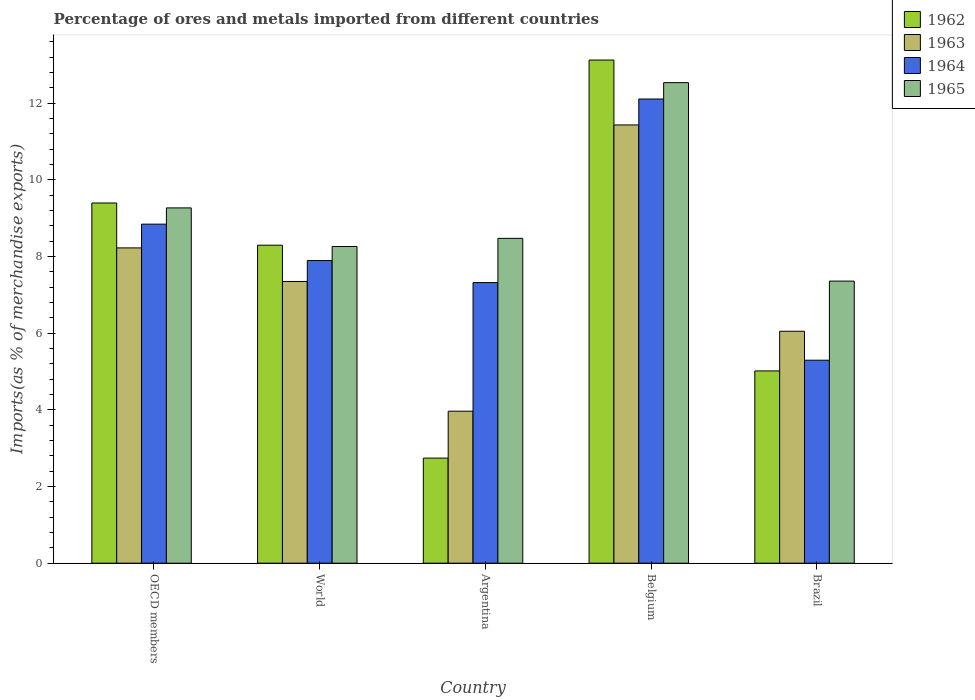How many groups of bars are there?
Your answer should be very brief. 5. Are the number of bars on each tick of the X-axis equal?
Provide a short and direct response. Yes. In how many cases, is the number of bars for a given country not equal to the number of legend labels?
Ensure brevity in your answer.  0. What is the percentage of imports to different countries in 1965 in World?
Give a very brief answer. 8.26. Across all countries, what is the maximum percentage of imports to different countries in 1964?
Provide a succinct answer. 12.11. Across all countries, what is the minimum percentage of imports to different countries in 1962?
Ensure brevity in your answer.  2.74. What is the total percentage of imports to different countries in 1962 in the graph?
Offer a terse response. 38.56. What is the difference between the percentage of imports to different countries in 1965 in Argentina and that in OECD members?
Give a very brief answer. -0.79. What is the difference between the percentage of imports to different countries in 1965 in World and the percentage of imports to different countries in 1964 in OECD members?
Your answer should be compact. -0.58. What is the average percentage of imports to different countries in 1965 per country?
Offer a terse response. 9.18. What is the difference between the percentage of imports to different countries of/in 1962 and percentage of imports to different countries of/in 1963 in Belgium?
Provide a short and direct response. 1.69. In how many countries, is the percentage of imports to different countries in 1965 greater than 0.4 %?
Offer a very short reply. 5. What is the ratio of the percentage of imports to different countries in 1965 in Brazil to that in OECD members?
Your answer should be compact. 0.79. Is the percentage of imports to different countries in 1964 in OECD members less than that in World?
Offer a terse response. No. Is the difference between the percentage of imports to different countries in 1962 in Argentina and World greater than the difference between the percentage of imports to different countries in 1963 in Argentina and World?
Make the answer very short. No. What is the difference between the highest and the second highest percentage of imports to different countries in 1964?
Provide a short and direct response. -3.26. What is the difference between the highest and the lowest percentage of imports to different countries in 1962?
Offer a terse response. 10.38. Is the sum of the percentage of imports to different countries in 1965 in Argentina and World greater than the maximum percentage of imports to different countries in 1963 across all countries?
Keep it short and to the point. Yes. What does the 3rd bar from the left in Argentina represents?
Provide a succinct answer. 1964. How many bars are there?
Ensure brevity in your answer.  20. How many countries are there in the graph?
Ensure brevity in your answer.  5. What is the difference between two consecutive major ticks on the Y-axis?
Offer a terse response. 2. How many legend labels are there?
Offer a very short reply. 4. What is the title of the graph?
Make the answer very short. Percentage of ores and metals imported from different countries. Does "1990" appear as one of the legend labels in the graph?
Provide a succinct answer. No. What is the label or title of the X-axis?
Provide a short and direct response. Country. What is the label or title of the Y-axis?
Make the answer very short. Imports(as % of merchandise exports). What is the Imports(as % of merchandise exports) in 1962 in OECD members?
Your answer should be very brief. 9.39. What is the Imports(as % of merchandise exports) of 1963 in OECD members?
Ensure brevity in your answer.  8.22. What is the Imports(as % of merchandise exports) of 1964 in OECD members?
Make the answer very short. 8.84. What is the Imports(as % of merchandise exports) in 1965 in OECD members?
Your answer should be compact. 9.27. What is the Imports(as % of merchandise exports) in 1962 in World?
Provide a succinct answer. 8.29. What is the Imports(as % of merchandise exports) in 1963 in World?
Your response must be concise. 7.35. What is the Imports(as % of merchandise exports) of 1964 in World?
Your response must be concise. 7.89. What is the Imports(as % of merchandise exports) of 1965 in World?
Give a very brief answer. 8.26. What is the Imports(as % of merchandise exports) of 1962 in Argentina?
Provide a succinct answer. 2.74. What is the Imports(as % of merchandise exports) of 1963 in Argentina?
Your response must be concise. 3.96. What is the Imports(as % of merchandise exports) of 1964 in Argentina?
Your answer should be very brief. 7.32. What is the Imports(as % of merchandise exports) in 1965 in Argentina?
Offer a terse response. 8.47. What is the Imports(as % of merchandise exports) of 1962 in Belgium?
Offer a terse response. 13.12. What is the Imports(as % of merchandise exports) in 1963 in Belgium?
Offer a terse response. 11.43. What is the Imports(as % of merchandise exports) of 1964 in Belgium?
Your response must be concise. 12.11. What is the Imports(as % of merchandise exports) in 1965 in Belgium?
Ensure brevity in your answer.  12.53. What is the Imports(as % of merchandise exports) of 1962 in Brazil?
Offer a terse response. 5.01. What is the Imports(as % of merchandise exports) of 1963 in Brazil?
Offer a very short reply. 6.05. What is the Imports(as % of merchandise exports) in 1964 in Brazil?
Offer a terse response. 5.29. What is the Imports(as % of merchandise exports) of 1965 in Brazil?
Offer a very short reply. 7.36. Across all countries, what is the maximum Imports(as % of merchandise exports) in 1962?
Your answer should be very brief. 13.12. Across all countries, what is the maximum Imports(as % of merchandise exports) in 1963?
Your answer should be compact. 11.43. Across all countries, what is the maximum Imports(as % of merchandise exports) in 1964?
Offer a very short reply. 12.11. Across all countries, what is the maximum Imports(as % of merchandise exports) in 1965?
Keep it short and to the point. 12.53. Across all countries, what is the minimum Imports(as % of merchandise exports) in 1962?
Give a very brief answer. 2.74. Across all countries, what is the minimum Imports(as % of merchandise exports) of 1963?
Offer a very short reply. 3.96. Across all countries, what is the minimum Imports(as % of merchandise exports) of 1964?
Give a very brief answer. 5.29. Across all countries, what is the minimum Imports(as % of merchandise exports) in 1965?
Provide a succinct answer. 7.36. What is the total Imports(as % of merchandise exports) in 1962 in the graph?
Give a very brief answer. 38.56. What is the total Imports(as % of merchandise exports) in 1963 in the graph?
Your answer should be very brief. 37.01. What is the total Imports(as % of merchandise exports) of 1964 in the graph?
Your answer should be compact. 41.45. What is the total Imports(as % of merchandise exports) of 1965 in the graph?
Offer a terse response. 45.89. What is the difference between the Imports(as % of merchandise exports) in 1962 in OECD members and that in World?
Your answer should be very brief. 1.1. What is the difference between the Imports(as % of merchandise exports) in 1963 in OECD members and that in World?
Make the answer very short. 0.88. What is the difference between the Imports(as % of merchandise exports) of 1964 in OECD members and that in World?
Your answer should be compact. 0.95. What is the difference between the Imports(as % of merchandise exports) in 1965 in OECD members and that in World?
Provide a short and direct response. 1.01. What is the difference between the Imports(as % of merchandise exports) of 1962 in OECD members and that in Argentina?
Offer a terse response. 6.65. What is the difference between the Imports(as % of merchandise exports) in 1963 in OECD members and that in Argentina?
Make the answer very short. 4.26. What is the difference between the Imports(as % of merchandise exports) of 1964 in OECD members and that in Argentina?
Offer a very short reply. 1.52. What is the difference between the Imports(as % of merchandise exports) of 1965 in OECD members and that in Argentina?
Make the answer very short. 0.79. What is the difference between the Imports(as % of merchandise exports) of 1962 in OECD members and that in Belgium?
Keep it short and to the point. -3.73. What is the difference between the Imports(as % of merchandise exports) of 1963 in OECD members and that in Belgium?
Your answer should be very brief. -3.21. What is the difference between the Imports(as % of merchandise exports) in 1964 in OECD members and that in Belgium?
Offer a very short reply. -3.26. What is the difference between the Imports(as % of merchandise exports) of 1965 in OECD members and that in Belgium?
Give a very brief answer. -3.27. What is the difference between the Imports(as % of merchandise exports) of 1962 in OECD members and that in Brazil?
Give a very brief answer. 4.38. What is the difference between the Imports(as % of merchandise exports) of 1963 in OECD members and that in Brazil?
Keep it short and to the point. 2.17. What is the difference between the Imports(as % of merchandise exports) of 1964 in OECD members and that in Brazil?
Give a very brief answer. 3.55. What is the difference between the Imports(as % of merchandise exports) in 1965 in OECD members and that in Brazil?
Offer a terse response. 1.91. What is the difference between the Imports(as % of merchandise exports) in 1962 in World and that in Argentina?
Your answer should be compact. 5.55. What is the difference between the Imports(as % of merchandise exports) of 1963 in World and that in Argentina?
Give a very brief answer. 3.38. What is the difference between the Imports(as % of merchandise exports) in 1964 in World and that in Argentina?
Give a very brief answer. 0.58. What is the difference between the Imports(as % of merchandise exports) in 1965 in World and that in Argentina?
Your answer should be very brief. -0.21. What is the difference between the Imports(as % of merchandise exports) in 1962 in World and that in Belgium?
Your response must be concise. -4.83. What is the difference between the Imports(as % of merchandise exports) of 1963 in World and that in Belgium?
Keep it short and to the point. -4.08. What is the difference between the Imports(as % of merchandise exports) of 1964 in World and that in Belgium?
Offer a very short reply. -4.21. What is the difference between the Imports(as % of merchandise exports) in 1965 in World and that in Belgium?
Make the answer very short. -4.27. What is the difference between the Imports(as % of merchandise exports) in 1962 in World and that in Brazil?
Your answer should be very brief. 3.28. What is the difference between the Imports(as % of merchandise exports) of 1963 in World and that in Brazil?
Offer a terse response. 1.3. What is the difference between the Imports(as % of merchandise exports) of 1964 in World and that in Brazil?
Make the answer very short. 2.6. What is the difference between the Imports(as % of merchandise exports) of 1965 in World and that in Brazil?
Your response must be concise. 0.9. What is the difference between the Imports(as % of merchandise exports) in 1962 in Argentina and that in Belgium?
Your answer should be very brief. -10.38. What is the difference between the Imports(as % of merchandise exports) in 1963 in Argentina and that in Belgium?
Make the answer very short. -7.46. What is the difference between the Imports(as % of merchandise exports) of 1964 in Argentina and that in Belgium?
Provide a short and direct response. -4.79. What is the difference between the Imports(as % of merchandise exports) in 1965 in Argentina and that in Belgium?
Offer a very short reply. -4.06. What is the difference between the Imports(as % of merchandise exports) of 1962 in Argentina and that in Brazil?
Make the answer very short. -2.27. What is the difference between the Imports(as % of merchandise exports) of 1963 in Argentina and that in Brazil?
Your answer should be very brief. -2.08. What is the difference between the Imports(as % of merchandise exports) of 1964 in Argentina and that in Brazil?
Keep it short and to the point. 2.02. What is the difference between the Imports(as % of merchandise exports) of 1965 in Argentina and that in Brazil?
Provide a succinct answer. 1.12. What is the difference between the Imports(as % of merchandise exports) in 1962 in Belgium and that in Brazil?
Offer a terse response. 8.11. What is the difference between the Imports(as % of merchandise exports) in 1963 in Belgium and that in Brazil?
Offer a terse response. 5.38. What is the difference between the Imports(as % of merchandise exports) of 1964 in Belgium and that in Brazil?
Your answer should be compact. 6.81. What is the difference between the Imports(as % of merchandise exports) in 1965 in Belgium and that in Brazil?
Make the answer very short. 5.18. What is the difference between the Imports(as % of merchandise exports) in 1962 in OECD members and the Imports(as % of merchandise exports) in 1963 in World?
Keep it short and to the point. 2.05. What is the difference between the Imports(as % of merchandise exports) in 1962 in OECD members and the Imports(as % of merchandise exports) in 1964 in World?
Your response must be concise. 1.5. What is the difference between the Imports(as % of merchandise exports) of 1962 in OECD members and the Imports(as % of merchandise exports) of 1965 in World?
Keep it short and to the point. 1.13. What is the difference between the Imports(as % of merchandise exports) in 1963 in OECD members and the Imports(as % of merchandise exports) in 1964 in World?
Give a very brief answer. 0.33. What is the difference between the Imports(as % of merchandise exports) of 1963 in OECD members and the Imports(as % of merchandise exports) of 1965 in World?
Your response must be concise. -0.04. What is the difference between the Imports(as % of merchandise exports) of 1964 in OECD members and the Imports(as % of merchandise exports) of 1965 in World?
Give a very brief answer. 0.58. What is the difference between the Imports(as % of merchandise exports) in 1962 in OECD members and the Imports(as % of merchandise exports) in 1963 in Argentina?
Your response must be concise. 5.43. What is the difference between the Imports(as % of merchandise exports) of 1962 in OECD members and the Imports(as % of merchandise exports) of 1964 in Argentina?
Provide a succinct answer. 2.08. What is the difference between the Imports(as % of merchandise exports) of 1962 in OECD members and the Imports(as % of merchandise exports) of 1965 in Argentina?
Make the answer very short. 0.92. What is the difference between the Imports(as % of merchandise exports) of 1963 in OECD members and the Imports(as % of merchandise exports) of 1964 in Argentina?
Your response must be concise. 0.9. What is the difference between the Imports(as % of merchandise exports) of 1963 in OECD members and the Imports(as % of merchandise exports) of 1965 in Argentina?
Make the answer very short. -0.25. What is the difference between the Imports(as % of merchandise exports) of 1964 in OECD members and the Imports(as % of merchandise exports) of 1965 in Argentina?
Provide a succinct answer. 0.37. What is the difference between the Imports(as % of merchandise exports) of 1962 in OECD members and the Imports(as % of merchandise exports) of 1963 in Belgium?
Offer a terse response. -2.04. What is the difference between the Imports(as % of merchandise exports) in 1962 in OECD members and the Imports(as % of merchandise exports) in 1964 in Belgium?
Give a very brief answer. -2.71. What is the difference between the Imports(as % of merchandise exports) in 1962 in OECD members and the Imports(as % of merchandise exports) in 1965 in Belgium?
Keep it short and to the point. -3.14. What is the difference between the Imports(as % of merchandise exports) of 1963 in OECD members and the Imports(as % of merchandise exports) of 1964 in Belgium?
Provide a succinct answer. -3.88. What is the difference between the Imports(as % of merchandise exports) of 1963 in OECD members and the Imports(as % of merchandise exports) of 1965 in Belgium?
Offer a very short reply. -4.31. What is the difference between the Imports(as % of merchandise exports) in 1964 in OECD members and the Imports(as % of merchandise exports) in 1965 in Belgium?
Offer a very short reply. -3.69. What is the difference between the Imports(as % of merchandise exports) in 1962 in OECD members and the Imports(as % of merchandise exports) in 1963 in Brazil?
Your answer should be very brief. 3.35. What is the difference between the Imports(as % of merchandise exports) in 1962 in OECD members and the Imports(as % of merchandise exports) in 1964 in Brazil?
Offer a terse response. 4.1. What is the difference between the Imports(as % of merchandise exports) in 1962 in OECD members and the Imports(as % of merchandise exports) in 1965 in Brazil?
Your response must be concise. 2.04. What is the difference between the Imports(as % of merchandise exports) in 1963 in OECD members and the Imports(as % of merchandise exports) in 1964 in Brazil?
Provide a short and direct response. 2.93. What is the difference between the Imports(as % of merchandise exports) of 1963 in OECD members and the Imports(as % of merchandise exports) of 1965 in Brazil?
Make the answer very short. 0.87. What is the difference between the Imports(as % of merchandise exports) in 1964 in OECD members and the Imports(as % of merchandise exports) in 1965 in Brazil?
Your response must be concise. 1.49. What is the difference between the Imports(as % of merchandise exports) of 1962 in World and the Imports(as % of merchandise exports) of 1963 in Argentina?
Your response must be concise. 4.33. What is the difference between the Imports(as % of merchandise exports) in 1962 in World and the Imports(as % of merchandise exports) in 1964 in Argentina?
Keep it short and to the point. 0.98. What is the difference between the Imports(as % of merchandise exports) in 1962 in World and the Imports(as % of merchandise exports) in 1965 in Argentina?
Ensure brevity in your answer.  -0.18. What is the difference between the Imports(as % of merchandise exports) of 1963 in World and the Imports(as % of merchandise exports) of 1964 in Argentina?
Provide a succinct answer. 0.03. What is the difference between the Imports(as % of merchandise exports) in 1963 in World and the Imports(as % of merchandise exports) in 1965 in Argentina?
Make the answer very short. -1.12. What is the difference between the Imports(as % of merchandise exports) in 1964 in World and the Imports(as % of merchandise exports) in 1965 in Argentina?
Your answer should be very brief. -0.58. What is the difference between the Imports(as % of merchandise exports) of 1962 in World and the Imports(as % of merchandise exports) of 1963 in Belgium?
Ensure brevity in your answer.  -3.14. What is the difference between the Imports(as % of merchandise exports) in 1962 in World and the Imports(as % of merchandise exports) in 1964 in Belgium?
Give a very brief answer. -3.81. What is the difference between the Imports(as % of merchandise exports) of 1962 in World and the Imports(as % of merchandise exports) of 1965 in Belgium?
Your answer should be very brief. -4.24. What is the difference between the Imports(as % of merchandise exports) of 1963 in World and the Imports(as % of merchandise exports) of 1964 in Belgium?
Your response must be concise. -4.76. What is the difference between the Imports(as % of merchandise exports) in 1963 in World and the Imports(as % of merchandise exports) in 1965 in Belgium?
Provide a short and direct response. -5.18. What is the difference between the Imports(as % of merchandise exports) in 1964 in World and the Imports(as % of merchandise exports) in 1965 in Belgium?
Ensure brevity in your answer.  -4.64. What is the difference between the Imports(as % of merchandise exports) in 1962 in World and the Imports(as % of merchandise exports) in 1963 in Brazil?
Give a very brief answer. 2.24. What is the difference between the Imports(as % of merchandise exports) in 1962 in World and the Imports(as % of merchandise exports) in 1964 in Brazil?
Ensure brevity in your answer.  3. What is the difference between the Imports(as % of merchandise exports) of 1962 in World and the Imports(as % of merchandise exports) of 1965 in Brazil?
Offer a very short reply. 0.94. What is the difference between the Imports(as % of merchandise exports) in 1963 in World and the Imports(as % of merchandise exports) in 1964 in Brazil?
Provide a short and direct response. 2.05. What is the difference between the Imports(as % of merchandise exports) in 1963 in World and the Imports(as % of merchandise exports) in 1965 in Brazil?
Offer a terse response. -0.01. What is the difference between the Imports(as % of merchandise exports) in 1964 in World and the Imports(as % of merchandise exports) in 1965 in Brazil?
Offer a very short reply. 0.54. What is the difference between the Imports(as % of merchandise exports) in 1962 in Argentina and the Imports(as % of merchandise exports) in 1963 in Belgium?
Give a very brief answer. -8.69. What is the difference between the Imports(as % of merchandise exports) in 1962 in Argentina and the Imports(as % of merchandise exports) in 1964 in Belgium?
Keep it short and to the point. -9.37. What is the difference between the Imports(as % of merchandise exports) in 1962 in Argentina and the Imports(as % of merchandise exports) in 1965 in Belgium?
Your answer should be very brief. -9.79. What is the difference between the Imports(as % of merchandise exports) of 1963 in Argentina and the Imports(as % of merchandise exports) of 1964 in Belgium?
Offer a very short reply. -8.14. What is the difference between the Imports(as % of merchandise exports) of 1963 in Argentina and the Imports(as % of merchandise exports) of 1965 in Belgium?
Keep it short and to the point. -8.57. What is the difference between the Imports(as % of merchandise exports) of 1964 in Argentina and the Imports(as % of merchandise exports) of 1965 in Belgium?
Make the answer very short. -5.21. What is the difference between the Imports(as % of merchandise exports) of 1962 in Argentina and the Imports(as % of merchandise exports) of 1963 in Brazil?
Provide a short and direct response. -3.31. What is the difference between the Imports(as % of merchandise exports) in 1962 in Argentina and the Imports(as % of merchandise exports) in 1964 in Brazil?
Provide a succinct answer. -2.55. What is the difference between the Imports(as % of merchandise exports) of 1962 in Argentina and the Imports(as % of merchandise exports) of 1965 in Brazil?
Your answer should be very brief. -4.62. What is the difference between the Imports(as % of merchandise exports) of 1963 in Argentina and the Imports(as % of merchandise exports) of 1964 in Brazil?
Ensure brevity in your answer.  -1.33. What is the difference between the Imports(as % of merchandise exports) of 1963 in Argentina and the Imports(as % of merchandise exports) of 1965 in Brazil?
Provide a succinct answer. -3.39. What is the difference between the Imports(as % of merchandise exports) of 1964 in Argentina and the Imports(as % of merchandise exports) of 1965 in Brazil?
Your answer should be compact. -0.04. What is the difference between the Imports(as % of merchandise exports) of 1962 in Belgium and the Imports(as % of merchandise exports) of 1963 in Brazil?
Offer a very short reply. 7.07. What is the difference between the Imports(as % of merchandise exports) in 1962 in Belgium and the Imports(as % of merchandise exports) in 1964 in Brazil?
Give a very brief answer. 7.83. What is the difference between the Imports(as % of merchandise exports) of 1962 in Belgium and the Imports(as % of merchandise exports) of 1965 in Brazil?
Make the answer very short. 5.77. What is the difference between the Imports(as % of merchandise exports) of 1963 in Belgium and the Imports(as % of merchandise exports) of 1964 in Brazil?
Ensure brevity in your answer.  6.14. What is the difference between the Imports(as % of merchandise exports) in 1963 in Belgium and the Imports(as % of merchandise exports) in 1965 in Brazil?
Keep it short and to the point. 4.07. What is the difference between the Imports(as % of merchandise exports) of 1964 in Belgium and the Imports(as % of merchandise exports) of 1965 in Brazil?
Your response must be concise. 4.75. What is the average Imports(as % of merchandise exports) in 1962 per country?
Offer a very short reply. 7.71. What is the average Imports(as % of merchandise exports) of 1963 per country?
Your answer should be compact. 7.4. What is the average Imports(as % of merchandise exports) of 1964 per country?
Provide a succinct answer. 8.29. What is the average Imports(as % of merchandise exports) of 1965 per country?
Offer a terse response. 9.18. What is the difference between the Imports(as % of merchandise exports) in 1962 and Imports(as % of merchandise exports) in 1963 in OECD members?
Provide a succinct answer. 1.17. What is the difference between the Imports(as % of merchandise exports) of 1962 and Imports(as % of merchandise exports) of 1964 in OECD members?
Give a very brief answer. 0.55. What is the difference between the Imports(as % of merchandise exports) of 1962 and Imports(as % of merchandise exports) of 1965 in OECD members?
Your answer should be compact. 0.13. What is the difference between the Imports(as % of merchandise exports) of 1963 and Imports(as % of merchandise exports) of 1964 in OECD members?
Provide a short and direct response. -0.62. What is the difference between the Imports(as % of merchandise exports) of 1963 and Imports(as % of merchandise exports) of 1965 in OECD members?
Your answer should be very brief. -1.04. What is the difference between the Imports(as % of merchandise exports) in 1964 and Imports(as % of merchandise exports) in 1965 in OECD members?
Offer a very short reply. -0.42. What is the difference between the Imports(as % of merchandise exports) in 1962 and Imports(as % of merchandise exports) in 1963 in World?
Your answer should be very brief. 0.95. What is the difference between the Imports(as % of merchandise exports) of 1962 and Imports(as % of merchandise exports) of 1964 in World?
Offer a terse response. 0.4. What is the difference between the Imports(as % of merchandise exports) of 1962 and Imports(as % of merchandise exports) of 1965 in World?
Make the answer very short. 0.03. What is the difference between the Imports(as % of merchandise exports) in 1963 and Imports(as % of merchandise exports) in 1964 in World?
Give a very brief answer. -0.55. What is the difference between the Imports(as % of merchandise exports) of 1963 and Imports(as % of merchandise exports) of 1965 in World?
Your answer should be very brief. -0.91. What is the difference between the Imports(as % of merchandise exports) of 1964 and Imports(as % of merchandise exports) of 1965 in World?
Keep it short and to the point. -0.37. What is the difference between the Imports(as % of merchandise exports) in 1962 and Imports(as % of merchandise exports) in 1963 in Argentina?
Ensure brevity in your answer.  -1.22. What is the difference between the Imports(as % of merchandise exports) of 1962 and Imports(as % of merchandise exports) of 1964 in Argentina?
Offer a terse response. -4.58. What is the difference between the Imports(as % of merchandise exports) in 1962 and Imports(as % of merchandise exports) in 1965 in Argentina?
Offer a terse response. -5.73. What is the difference between the Imports(as % of merchandise exports) of 1963 and Imports(as % of merchandise exports) of 1964 in Argentina?
Provide a short and direct response. -3.35. What is the difference between the Imports(as % of merchandise exports) of 1963 and Imports(as % of merchandise exports) of 1965 in Argentina?
Provide a succinct answer. -4.51. What is the difference between the Imports(as % of merchandise exports) of 1964 and Imports(as % of merchandise exports) of 1965 in Argentina?
Keep it short and to the point. -1.15. What is the difference between the Imports(as % of merchandise exports) in 1962 and Imports(as % of merchandise exports) in 1963 in Belgium?
Give a very brief answer. 1.69. What is the difference between the Imports(as % of merchandise exports) in 1962 and Imports(as % of merchandise exports) in 1965 in Belgium?
Keep it short and to the point. 0.59. What is the difference between the Imports(as % of merchandise exports) of 1963 and Imports(as % of merchandise exports) of 1964 in Belgium?
Give a very brief answer. -0.68. What is the difference between the Imports(as % of merchandise exports) of 1963 and Imports(as % of merchandise exports) of 1965 in Belgium?
Provide a short and direct response. -1.1. What is the difference between the Imports(as % of merchandise exports) in 1964 and Imports(as % of merchandise exports) in 1965 in Belgium?
Ensure brevity in your answer.  -0.43. What is the difference between the Imports(as % of merchandise exports) in 1962 and Imports(as % of merchandise exports) in 1963 in Brazil?
Ensure brevity in your answer.  -1.03. What is the difference between the Imports(as % of merchandise exports) of 1962 and Imports(as % of merchandise exports) of 1964 in Brazil?
Provide a succinct answer. -0.28. What is the difference between the Imports(as % of merchandise exports) in 1962 and Imports(as % of merchandise exports) in 1965 in Brazil?
Provide a succinct answer. -2.34. What is the difference between the Imports(as % of merchandise exports) of 1963 and Imports(as % of merchandise exports) of 1964 in Brazil?
Provide a short and direct response. 0.75. What is the difference between the Imports(as % of merchandise exports) of 1963 and Imports(as % of merchandise exports) of 1965 in Brazil?
Offer a very short reply. -1.31. What is the difference between the Imports(as % of merchandise exports) of 1964 and Imports(as % of merchandise exports) of 1965 in Brazil?
Your answer should be compact. -2.06. What is the ratio of the Imports(as % of merchandise exports) of 1962 in OECD members to that in World?
Your response must be concise. 1.13. What is the ratio of the Imports(as % of merchandise exports) of 1963 in OECD members to that in World?
Ensure brevity in your answer.  1.12. What is the ratio of the Imports(as % of merchandise exports) in 1964 in OECD members to that in World?
Ensure brevity in your answer.  1.12. What is the ratio of the Imports(as % of merchandise exports) in 1965 in OECD members to that in World?
Your answer should be compact. 1.12. What is the ratio of the Imports(as % of merchandise exports) of 1962 in OECD members to that in Argentina?
Offer a terse response. 3.43. What is the ratio of the Imports(as % of merchandise exports) in 1963 in OECD members to that in Argentina?
Keep it short and to the point. 2.07. What is the ratio of the Imports(as % of merchandise exports) in 1964 in OECD members to that in Argentina?
Provide a succinct answer. 1.21. What is the ratio of the Imports(as % of merchandise exports) in 1965 in OECD members to that in Argentina?
Your answer should be very brief. 1.09. What is the ratio of the Imports(as % of merchandise exports) of 1962 in OECD members to that in Belgium?
Your answer should be compact. 0.72. What is the ratio of the Imports(as % of merchandise exports) of 1963 in OECD members to that in Belgium?
Your answer should be very brief. 0.72. What is the ratio of the Imports(as % of merchandise exports) of 1964 in OECD members to that in Belgium?
Make the answer very short. 0.73. What is the ratio of the Imports(as % of merchandise exports) of 1965 in OECD members to that in Belgium?
Your response must be concise. 0.74. What is the ratio of the Imports(as % of merchandise exports) in 1962 in OECD members to that in Brazil?
Offer a very short reply. 1.87. What is the ratio of the Imports(as % of merchandise exports) in 1963 in OECD members to that in Brazil?
Ensure brevity in your answer.  1.36. What is the ratio of the Imports(as % of merchandise exports) of 1964 in OECD members to that in Brazil?
Make the answer very short. 1.67. What is the ratio of the Imports(as % of merchandise exports) of 1965 in OECD members to that in Brazil?
Make the answer very short. 1.26. What is the ratio of the Imports(as % of merchandise exports) of 1962 in World to that in Argentina?
Provide a short and direct response. 3.03. What is the ratio of the Imports(as % of merchandise exports) in 1963 in World to that in Argentina?
Keep it short and to the point. 1.85. What is the ratio of the Imports(as % of merchandise exports) of 1964 in World to that in Argentina?
Your answer should be very brief. 1.08. What is the ratio of the Imports(as % of merchandise exports) of 1965 in World to that in Argentina?
Offer a terse response. 0.97. What is the ratio of the Imports(as % of merchandise exports) in 1962 in World to that in Belgium?
Provide a succinct answer. 0.63. What is the ratio of the Imports(as % of merchandise exports) in 1963 in World to that in Belgium?
Your response must be concise. 0.64. What is the ratio of the Imports(as % of merchandise exports) of 1964 in World to that in Belgium?
Offer a very short reply. 0.65. What is the ratio of the Imports(as % of merchandise exports) of 1965 in World to that in Belgium?
Make the answer very short. 0.66. What is the ratio of the Imports(as % of merchandise exports) in 1962 in World to that in Brazil?
Your answer should be compact. 1.65. What is the ratio of the Imports(as % of merchandise exports) in 1963 in World to that in Brazil?
Your answer should be compact. 1.21. What is the ratio of the Imports(as % of merchandise exports) of 1964 in World to that in Brazil?
Your answer should be compact. 1.49. What is the ratio of the Imports(as % of merchandise exports) in 1965 in World to that in Brazil?
Ensure brevity in your answer.  1.12. What is the ratio of the Imports(as % of merchandise exports) in 1962 in Argentina to that in Belgium?
Offer a very short reply. 0.21. What is the ratio of the Imports(as % of merchandise exports) of 1963 in Argentina to that in Belgium?
Your response must be concise. 0.35. What is the ratio of the Imports(as % of merchandise exports) of 1964 in Argentina to that in Belgium?
Keep it short and to the point. 0.6. What is the ratio of the Imports(as % of merchandise exports) of 1965 in Argentina to that in Belgium?
Your answer should be very brief. 0.68. What is the ratio of the Imports(as % of merchandise exports) in 1962 in Argentina to that in Brazil?
Provide a succinct answer. 0.55. What is the ratio of the Imports(as % of merchandise exports) in 1963 in Argentina to that in Brazil?
Ensure brevity in your answer.  0.66. What is the ratio of the Imports(as % of merchandise exports) of 1964 in Argentina to that in Brazil?
Provide a succinct answer. 1.38. What is the ratio of the Imports(as % of merchandise exports) in 1965 in Argentina to that in Brazil?
Your answer should be compact. 1.15. What is the ratio of the Imports(as % of merchandise exports) of 1962 in Belgium to that in Brazil?
Provide a short and direct response. 2.62. What is the ratio of the Imports(as % of merchandise exports) of 1963 in Belgium to that in Brazil?
Keep it short and to the point. 1.89. What is the ratio of the Imports(as % of merchandise exports) of 1964 in Belgium to that in Brazil?
Your answer should be compact. 2.29. What is the ratio of the Imports(as % of merchandise exports) in 1965 in Belgium to that in Brazil?
Ensure brevity in your answer.  1.7. What is the difference between the highest and the second highest Imports(as % of merchandise exports) of 1962?
Make the answer very short. 3.73. What is the difference between the highest and the second highest Imports(as % of merchandise exports) in 1963?
Offer a very short reply. 3.21. What is the difference between the highest and the second highest Imports(as % of merchandise exports) in 1964?
Make the answer very short. 3.26. What is the difference between the highest and the second highest Imports(as % of merchandise exports) of 1965?
Ensure brevity in your answer.  3.27. What is the difference between the highest and the lowest Imports(as % of merchandise exports) of 1962?
Your answer should be very brief. 10.38. What is the difference between the highest and the lowest Imports(as % of merchandise exports) in 1963?
Keep it short and to the point. 7.46. What is the difference between the highest and the lowest Imports(as % of merchandise exports) in 1964?
Your answer should be very brief. 6.81. What is the difference between the highest and the lowest Imports(as % of merchandise exports) in 1965?
Offer a terse response. 5.18. 